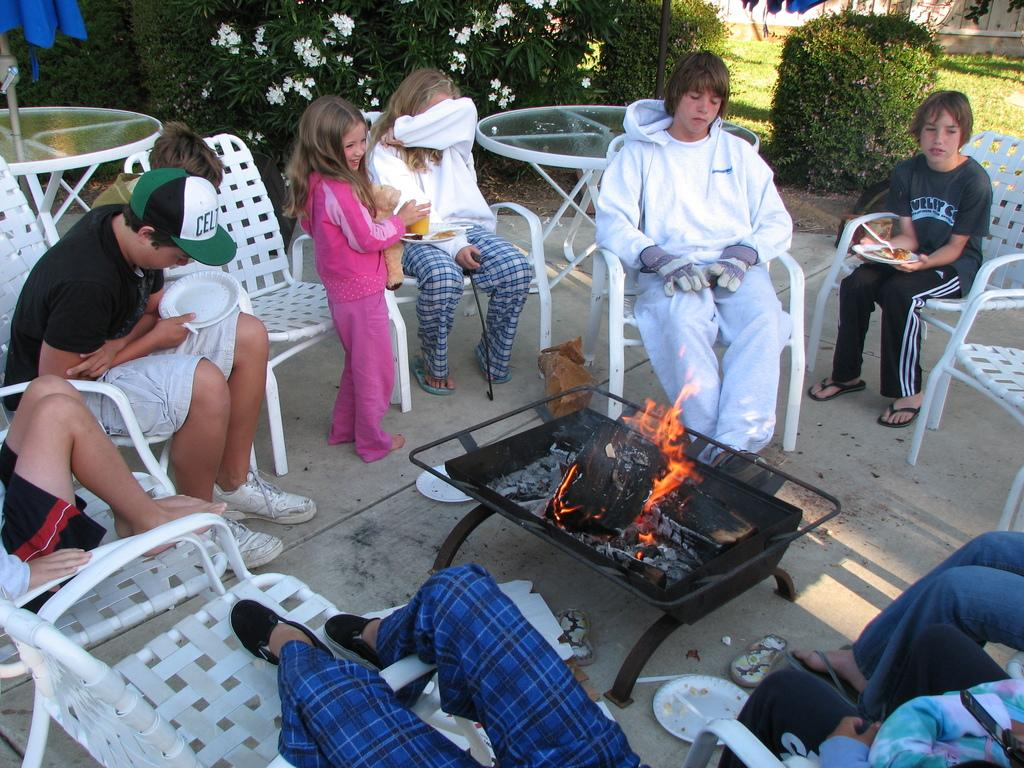<image>
Write a terse but informative summary of the picture. the team name Celtics is on a boy's hat 